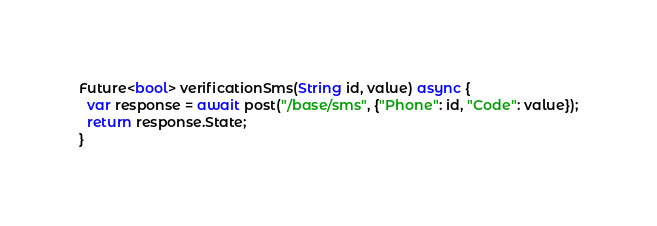<code> <loc_0><loc_0><loc_500><loc_500><_Dart_>Future<bool> verificationSms(String id, value) async {
  var response = await post("/base/sms", {"Phone": id, "Code": value});
  return response.State;
}
</code> 